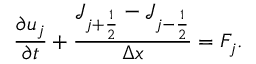Convert formula to latex. <formula><loc_0><loc_0><loc_500><loc_500>\frac { \partial u _ { j } } { \partial t } + \frac { \mathcal { J } _ { j + \frac { 1 } { 2 } } - \mathcal { J } _ { j - \frac { 1 } { 2 } } } { \Delta x } = F _ { j } .</formula> 